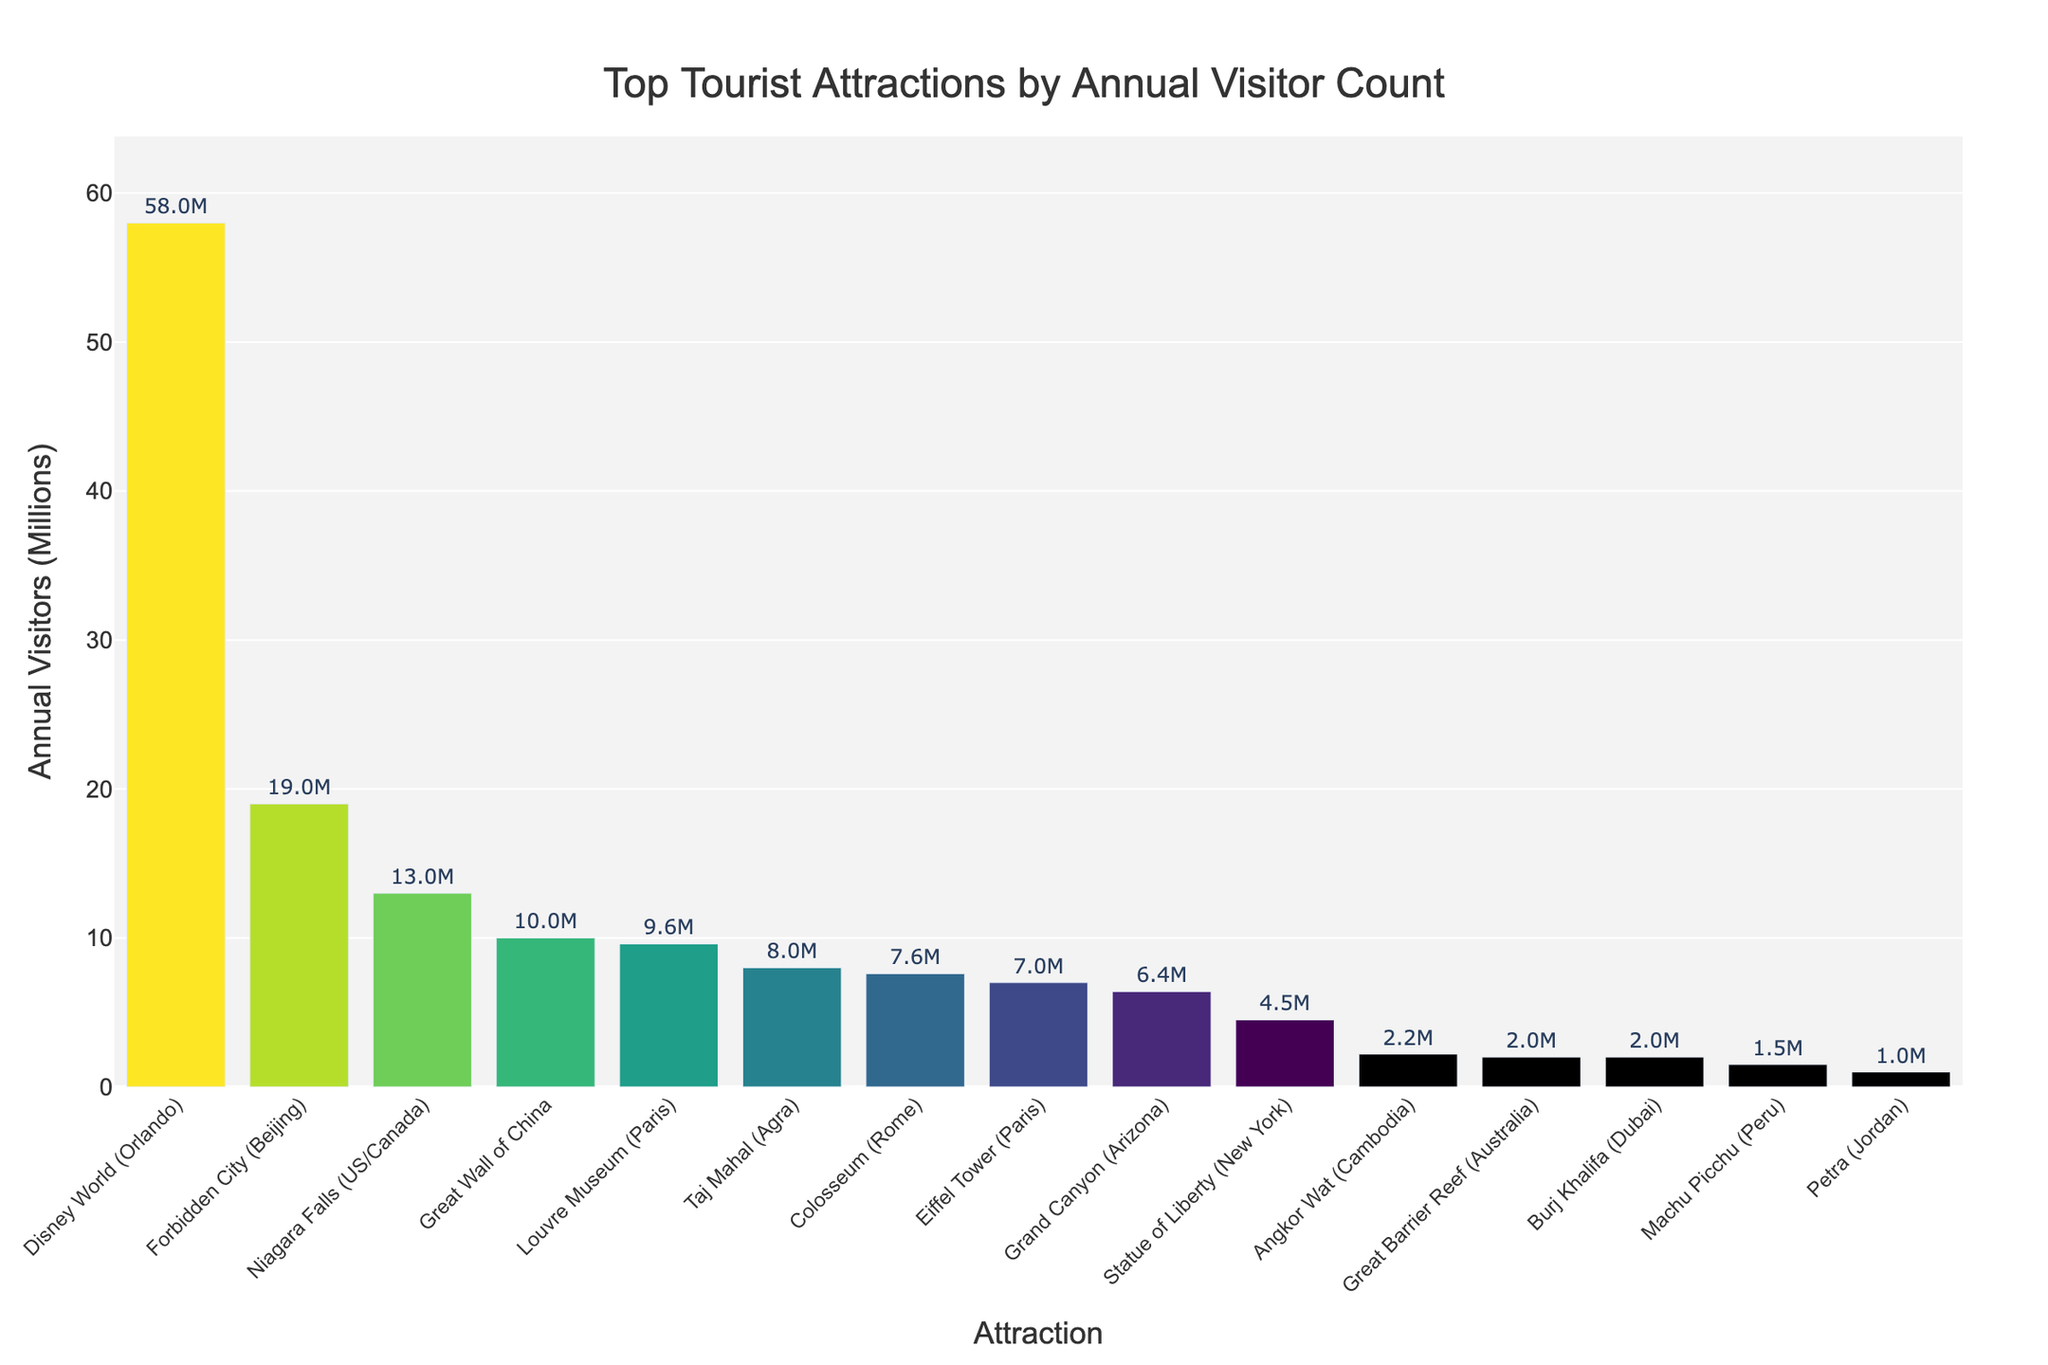Which tourist attraction has the highest annual visitor count? Disney World in Orlando has the highest bar among all attractions, indicating it has the highest annual visitor count.
Answer: Disney World What is the difference in annual visitors between the Forbidden City and the Eiffel Tower? The bar for the Forbidden City shows 19 million visitors, and the bar for the Eiffel Tower shows 7 million. Subtracting these numbers gives 19 - 7 = 12 million.
Answer: 12 million Which attractions have fewer annual visitors than the Grand Canyon? Bars for the Grand Canyon show 6.4 million visitors. Counting all bars shorter than this, we find the Eiffel Tower (7), Statue of Liberty (4.5), Machu Picchu (1.5), Petra (1), Angkor Wat (2.2), Great Barrier Reef (2), and Burj Khalifa (2) have fewer visitors.
Answer: Eiffel Tower, Statue of Liberty, Machu Picchu, Petra, Angkor Wat, Great Barrier Reef, Burj Khalifa What is the sum of annual visitors for the Great Wall of China and the Taj Mahal? The bar for the Great Wall of China indicates 10 million visitors, and the bar for the Taj Mahal indicates 8 million visitors. Adding these gives 10 + 8 = 18 million visitors.
Answer: 18 million Which tourist attraction has the lowest annual visitor count? The shortest bar on the chart represents Petra, indicating it has the lowest annual visitor count.
Answer: Petra How does the annual visitor count for the Louvre Museum compare to Niagara Falls? The bar for the Louvre Museum shows 9.6 million visitors, while the bar for Niagara Falls shows 13 million visitors. Niagara Falls has a higher count as its bar is taller.
Answer: Niagara Falls has more visitors What is the average annual visitor count among the top 10 attractions? Summing the visitor counts for the top 10 attractions (58 + 19 + 13 + 10 + 9.6 + 7.6 + 7 + 6.4 + 4.5 + 2.2) and then dividing by 10 gives (137.3/10) = 13.73 million.
Answer: 13.73 million Are there any attractions in the top 10 list from South America? Checking the attraction names and regions visually, we see Machu Picchu (Peru) is the only one from South America.
Answer: Machu Picchu Which two attractions have nearly equal annual visitor counts and what are those counts? The bars for the Eiffel Tower and the Colosseum appear to be almost the same height, indicating they have nearly equal counts. Both have visitor counts of around 7 million.
Answer: Eiffel Tower and Colosseum, 7 million each What's the median annual visitor count of the listed attractions? When listing the visitor counts in ascending order (1, 1.5, 2, 2.2, 4.5, 6.4, 7, 7.6, 8, 9.6, 10, 13, 19, 58), the middle value (or average of the two middle values if even) is the median. The median count is 7.6 million.
Answer: 7.6 million 